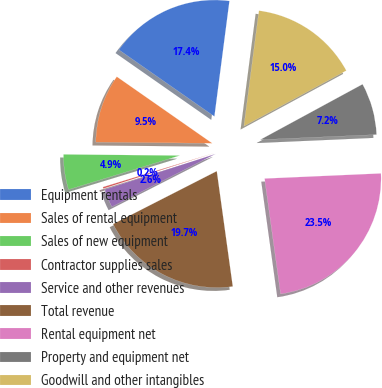<chart> <loc_0><loc_0><loc_500><loc_500><pie_chart><fcel>Equipment rentals<fcel>Sales of rental equipment<fcel>Sales of new equipment<fcel>Contractor supplies sales<fcel>Service and other revenues<fcel>Total revenue<fcel>Rental equipment net<fcel>Property and equipment net<fcel>Goodwill and other intangibles<nl><fcel>17.36%<fcel>9.54%<fcel>4.88%<fcel>0.23%<fcel>2.56%<fcel>19.68%<fcel>23.51%<fcel>7.21%<fcel>15.03%<nl></chart> 